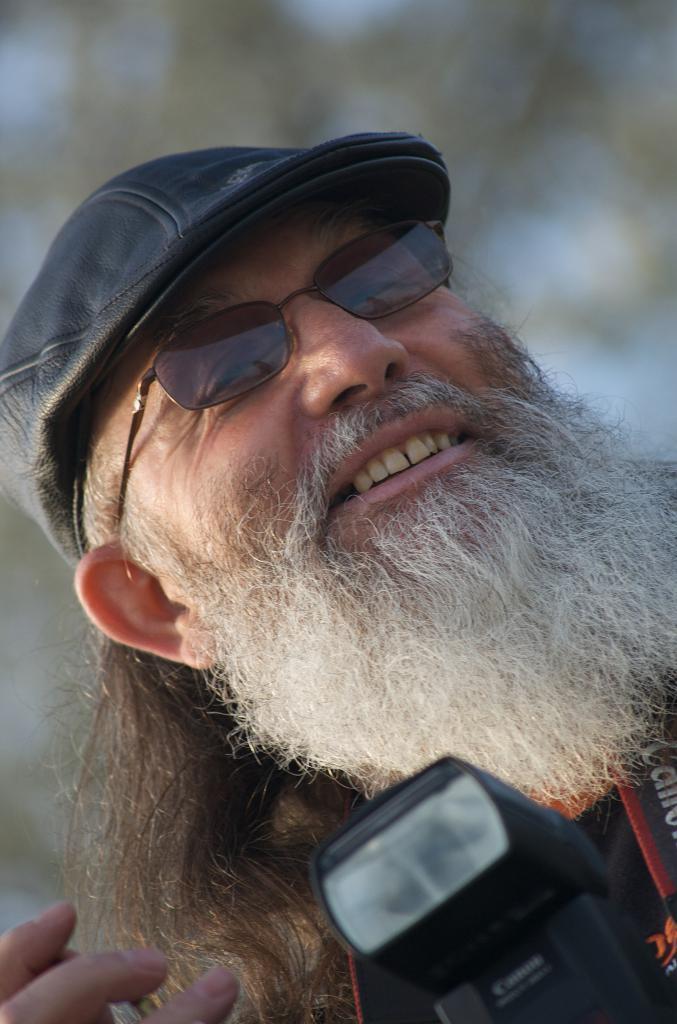Can you describe this image briefly? In this image, I can see a man smiling. At the bottom of the image, I can see a camera. There is a blurred background. 